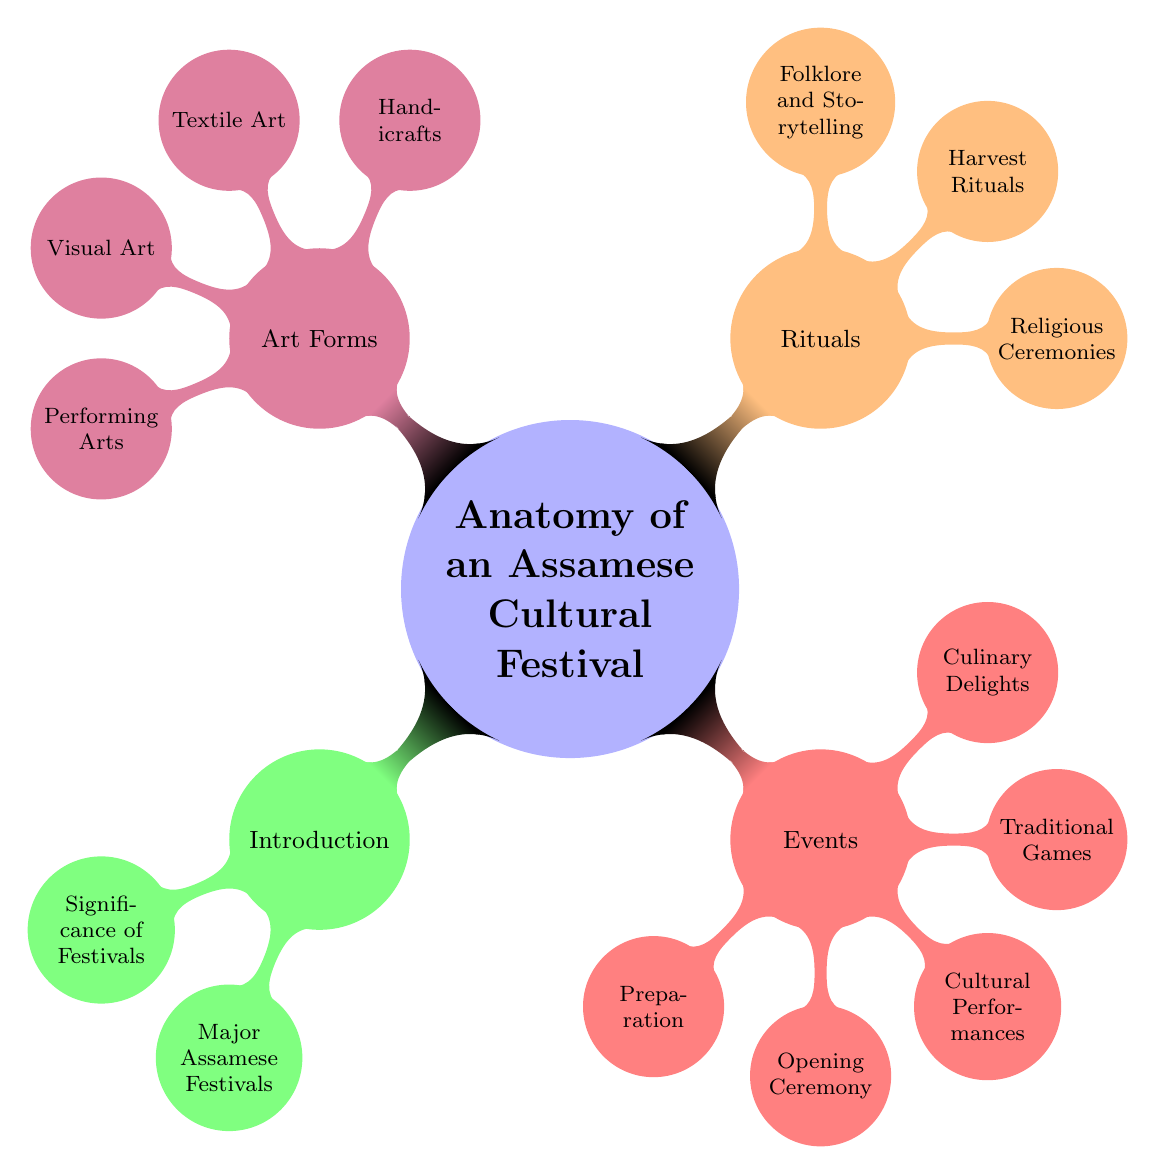What is the main title of the diagram? The diagram's main title is clearly indicated at the top as "Anatomy of an Assamese Cultural Festival." This title summarizes the overall theme of the diagram.
Answer: Anatomy of an Assamese Cultural Festival How many major categories are represented in the diagram? The diagram has four major categories: Introduction, Events, Rituals, and Art Forms. This can be counted based on the first level of branches from the central node.
Answer: 4 What node corresponds to the culinary aspects of the festival? The culinary aspects are represented by the node labeled "Culinary Delights," which is part of the "Events" category.
Answer: Culinary Delights Which category includes storytelling? Storytelling is included in the "Rituals" category as noted by the node labeled "Folklore and Storytelling." This information can be traced by following the branches from the central node.
Answer: Rituals What are the two types of art mentioned in the diagram? The two types of art mentioned in the diagram are "Handicrafts" and "Textile Art." Both belong to the "Art Forms" category, and they can be identified by the respective nodes under that category.
Answer: Handicrafts, Textile Art Which event occurs before "Cultural Performances"? The event that occurs before "Cultural Performances" is "Opening Ceremony," which is identified as a sibling node in the same category and comes first in the listing.
Answer: Opening Ceremony What is the color designation for the "Rituals" category? The "Rituals" category is represented in orange, as indicated by the color coding used in the diagram. This color is used for its associated category node and its children.
Answer: Orange Total number of nodes under "Art Forms" Under "Art Forms," there are four specific nodes: Handicrafts, Textile Art, Visual Art, and Performing Arts. Counting them gives a total of four.
Answer: 4 Which category includes the "Harvest Rituals"? The "Harvest Rituals" are included in the "Rituals" category. This can be determined by tracing the connection from the central node to the respective child node.
Answer: Rituals 